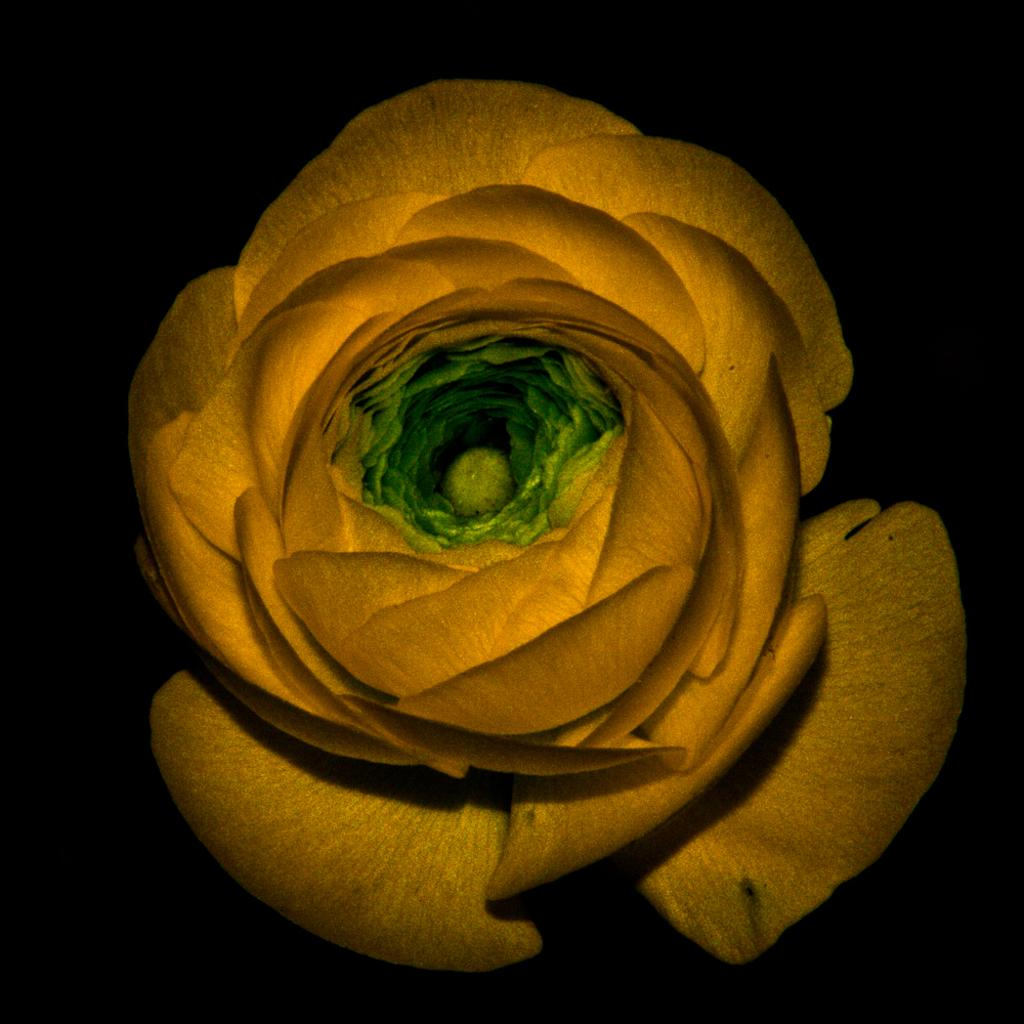What can be seen in the image? There is an object in the image. Can you describe the appearance of the object? The object is yellow and green in color. Is there a wrist with a cast visible in the image? No, there is no wrist or cast present in the image. Can you see a railway in the image? No, there is no railway present in the image. 